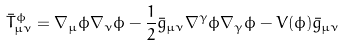Convert formula to latex. <formula><loc_0><loc_0><loc_500><loc_500>\bar { T } ^ { \phi } _ { \mu \nu } = \nabla _ { \mu } \phi \nabla _ { \nu } \phi - \frac { 1 } { 2 } \bar { g } _ { \mu \nu } \nabla ^ { \gamma } \phi \nabla _ { \gamma } \phi - V ( \phi ) \bar { g } _ { \mu \nu }</formula> 